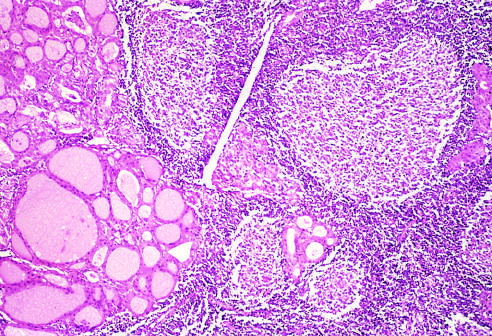what does the thyroid parenchyma contain?
Answer the question using a single word or phrase. A dense lymphocytic infiltrate with germinal centers 